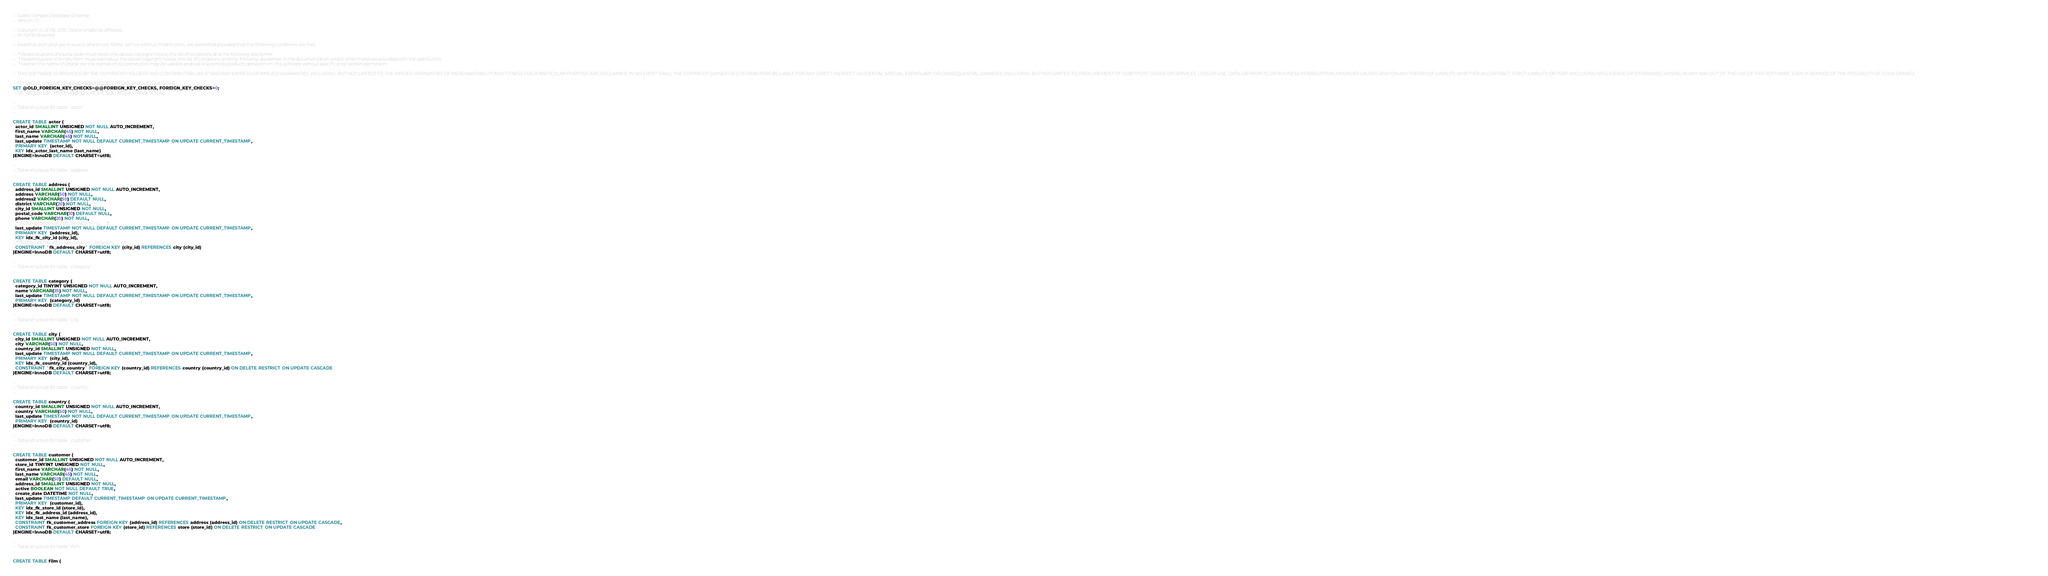<code> <loc_0><loc_0><loc_500><loc_500><_SQL_>-- Sakila Sample Database Schema
-- Version 1.0

-- Copyright (c) 2006, 2015, Oracle and/or its affiliates. 
-- All rights reserved.

-- Redistribution and use in source and binary forms, with or without modification, are permitted provided that the following conditions are met:

--  * Redistributions of source code must retain the above copyright notice, this list of conditions and the following disclaimer.
--  * Redistributions in binary form must reproduce the above copyright notice, this list of conditions and the following disclaimer in the documentation and/or other materials provided with the distribution.
--  * Neither the name of Oracle nor the names of its contributors may be used to endorse or promote products derived from this software without specific prior written permission.

-- THIS SOFTWARE IS PROVIDED BY THE COPYRIGHT HOLDERS AND CONTRIBUTORS "AS IS" AND ANY EXPRESS OR IMPLIED WARRANTIES, INCLUDING, BUT NOT LIMITED TO, THE IMPLIED WARRANTIES OF MERCHANTABILITY AND FITNESS FOR A PARTICULAR PURPOSE ARE DISCLAIMED. IN NO EVENT SHALL THE COPYRIGHT OWNER OR CONTRIBUTORS BE LIABLE FOR ANY DIRECT, INDIRECT, INCIDENTAL, SPECIAL, EXEMPLARY, OR CONSEQUENTIAL DAMAGES (INCLUDING, BUT NOT LIMITED TO, PROCUREMENT OF SUBSTITUTE GOODS OR SERVICES; LOSS OF USE, DATA, OR PROFITS; OR BUSINESS INTERRUPTION) HOWEVER CAUSED AND ON ANY THEORY OF LIABILITY, WHETHER IN CONTRACT, STRICT LIABILITY, OR TORT (INCLUDING NEGLIGENCE OR OTHERWISE) ARISING IN ANY WAY OUT OF THE USE OF THIS SOFTWARE, EVEN IF ADVISED OF THE POSSIBILITY OF SUCH DAMAGE.

-- SET @OLD_UNIQUE_CHECKS=@@UNIQUE_CHECKS, UNIQUE_CHECKS=0;
SET @OLD_FOREIGN_KEY_CHECKS=@@FOREIGN_KEY_CHECKS, FOREIGN_KEY_CHECKS=0;
-- SET @OLD_SQL_MODE=@@SQL_MODE, SQL_MODE='TRADITIONAL';

--
-- Table structure for table `actor`
--

CREATE TABLE actor (
  actor_id SMALLINT UNSIGNED NOT NULL AUTO_INCREMENT,
  first_name VARCHAR(45) NOT NULL,
  last_name VARCHAR(45) NOT NULL,
  last_update TIMESTAMP NOT NULL DEFAULT CURRENT_TIMESTAMP ON UPDATE CURRENT_TIMESTAMP,
  PRIMARY KEY  (actor_id),
  KEY idx_actor_last_name (last_name)
)ENGINE=InnoDB DEFAULT CHARSET=utf8;

--
-- Table structure for table `address`
--

CREATE TABLE address (
  address_id SMALLINT UNSIGNED NOT NULL AUTO_INCREMENT,
  address VARCHAR(50) NOT NULL,
  address2 VARCHAR(50) DEFAULT NULL,
  district VARCHAR(20) NOT NULL,
  city_id SMALLINT UNSIGNED NOT NULL,
  postal_code VARCHAR(10) DEFAULT NULL,
  phone VARCHAR(20) NOT NULL,
  /*!50705 location GEOMETRY NOT NULL,*/
  last_update TIMESTAMP NOT NULL DEFAULT CURRENT_TIMESTAMP ON UPDATE CURRENT_TIMESTAMP,
  PRIMARY KEY  (address_id),
  KEY idx_fk_city_id (city_id),
  /*!50705 SPATIAL KEY `idx_location` (location),*/
  CONSTRAINT `fk_address_city` FOREIGN KEY (city_id) REFERENCES city (city_id)
)ENGINE=InnoDB DEFAULT CHARSET=utf8;

--
-- Table structure for table `category`
--

CREATE TABLE category (
  category_id TINYINT UNSIGNED NOT NULL AUTO_INCREMENT,
  name VARCHAR(25) NOT NULL,
  last_update TIMESTAMP NOT NULL DEFAULT CURRENT_TIMESTAMP ON UPDATE CURRENT_TIMESTAMP,
  PRIMARY KEY  (category_id)
)ENGINE=InnoDB DEFAULT CHARSET=utf8;

--
-- Table structure for table `city`
--

CREATE TABLE city (
  city_id SMALLINT UNSIGNED NOT NULL AUTO_INCREMENT,
  city VARCHAR(50) NOT NULL,
  country_id SMALLINT UNSIGNED NOT NULL,
  last_update TIMESTAMP NOT NULL DEFAULT CURRENT_TIMESTAMP ON UPDATE CURRENT_TIMESTAMP,
  PRIMARY KEY  (city_id),
  KEY idx_fk_country_id (country_id),
  CONSTRAINT `fk_city_country` FOREIGN KEY (country_id) REFERENCES country (country_id) ON DELETE RESTRICT ON UPDATE CASCADE
)ENGINE=InnoDB DEFAULT CHARSET=utf8;

--
-- Table structure for table `country`
--

CREATE TABLE country (
  country_id SMALLINT UNSIGNED NOT NULL AUTO_INCREMENT,
  country VARCHAR(50) NOT NULL,
  last_update TIMESTAMP NOT NULL DEFAULT CURRENT_TIMESTAMP ON UPDATE CURRENT_TIMESTAMP,
  PRIMARY KEY  (country_id)
)ENGINE=InnoDB DEFAULT CHARSET=utf8;

--
-- Table structure for table `customer`
--

CREATE TABLE customer (
  customer_id SMALLINT UNSIGNED NOT NULL AUTO_INCREMENT,
  store_id TINYINT UNSIGNED NOT NULL,
  first_name VARCHAR(45) NOT NULL,
  last_name VARCHAR(45) NOT NULL,
  email VARCHAR(50) DEFAULT NULL,
  address_id SMALLINT UNSIGNED NOT NULL,
  active BOOLEAN NOT NULL DEFAULT TRUE,
  create_date DATETIME NOT NULL,
  last_update TIMESTAMP DEFAULT CURRENT_TIMESTAMP ON UPDATE CURRENT_TIMESTAMP,
  PRIMARY KEY  (customer_id),
  KEY idx_fk_store_id (store_id),
  KEY idx_fk_address_id (address_id),
  KEY idx_last_name (last_name),
  CONSTRAINT fk_customer_address FOREIGN KEY (address_id) REFERENCES address (address_id) ON DELETE RESTRICT ON UPDATE CASCADE,
  CONSTRAINT fk_customer_store FOREIGN KEY (store_id) REFERENCES store (store_id) ON DELETE RESTRICT ON UPDATE CASCADE
)ENGINE=InnoDB DEFAULT CHARSET=utf8;

--
-- Table structure for table `film`
--

CREATE TABLE film (</code> 